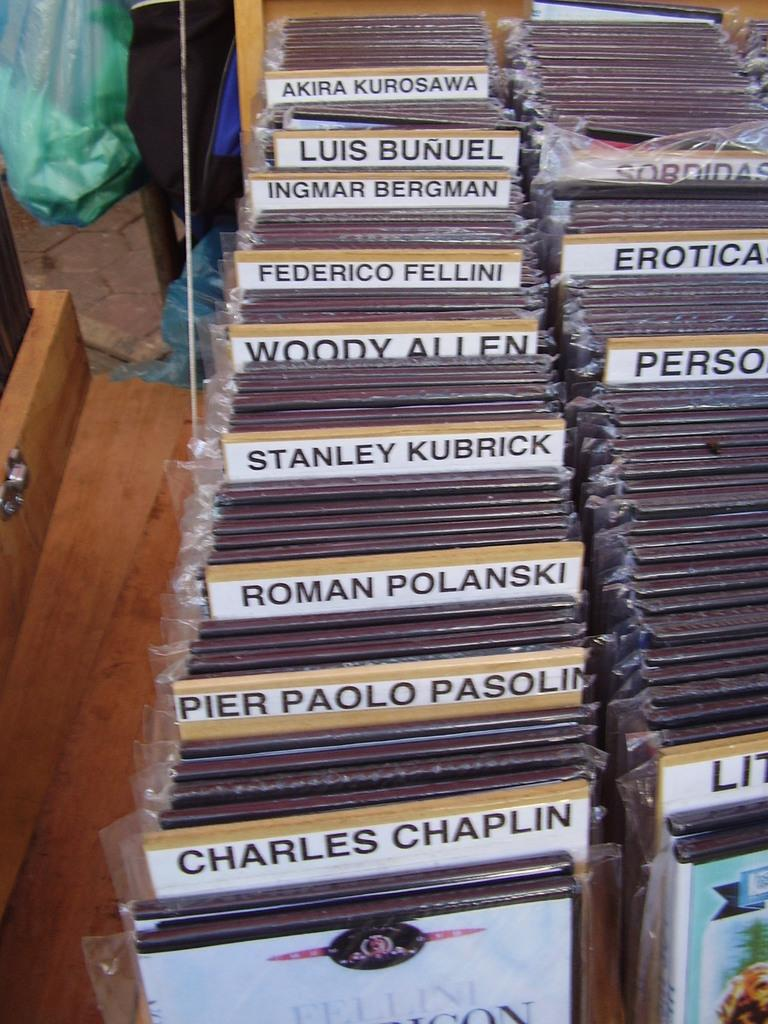What type of material is used for the boards in the image? The facts provided do not specify the material of the boards. What is covering the boards in the image? There are plastic covers in the image. Can you describe any other objects present in the image? The facts provided only mention boards and plastic covers, so it is not possible to describe any other objects. How many people are crying at the party in the image? There is no party or people crying in the image; it only features boards and plastic covers. 